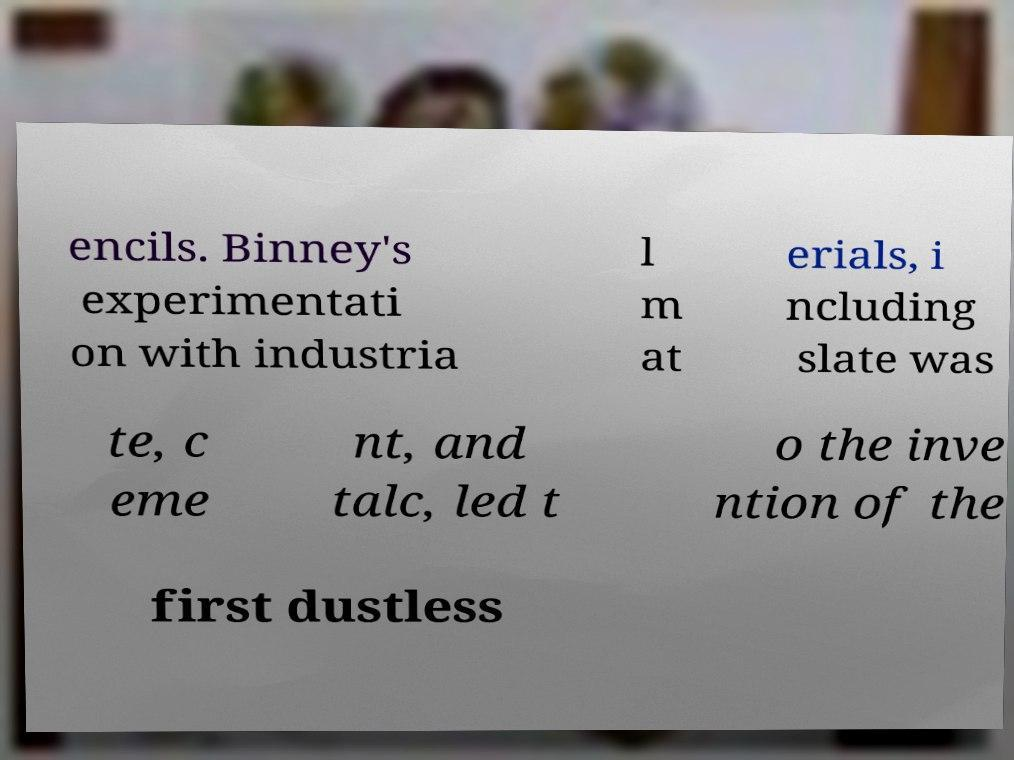There's text embedded in this image that I need extracted. Can you transcribe it verbatim? encils. Binney's experimentati on with industria l m at erials, i ncluding slate was te, c eme nt, and talc, led t o the inve ntion of the first dustless 